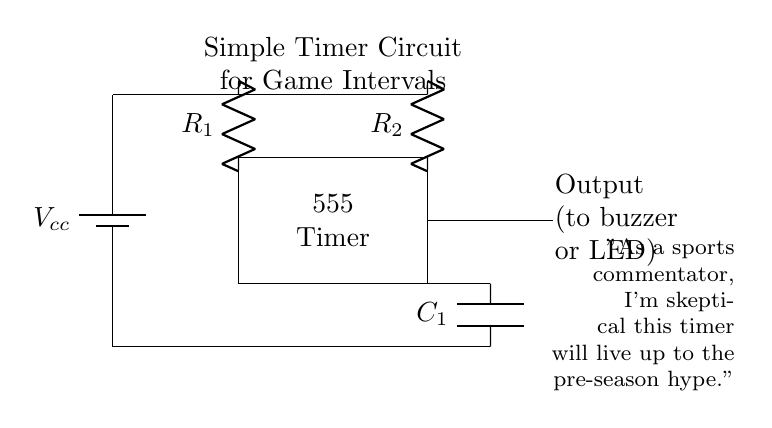What is the main function of the 555 Timer in this circuit? The 555 Timer is being used as a timing device to track game intervals, allowing for accurate measurement of timeouts.
Answer: timing device What components are used in this circuit? The circuit consists of a battery, a 555 Timer IC, two resistors, and one capacitor, which are all essential for its operation.
Answer: battery, 555 Timer, resistors, capacitor How many resistors are present in the circuit? There are two resistors connected in the circuit, specified as R1 and R2, which influence the timing characteristics.
Answer: two What is the role of the capacitor in this circuit? The capacitor C1 is essential for defining the timing intervals alongside the resistors, affecting how long the timer stays on or off.
Answer: timing intervals What does the output connect to? The output of the timer circuit connects to a buzzer or an LED, which is used to indicate the end of a game interval or timeout.
Answer: buzzer or LED What does Vcc represent in this circuit? Vcc represents the supply voltage that powers the entire circuit. It is essential for the operation of all components, especially the 555 Timer.
Answer: supply voltage 